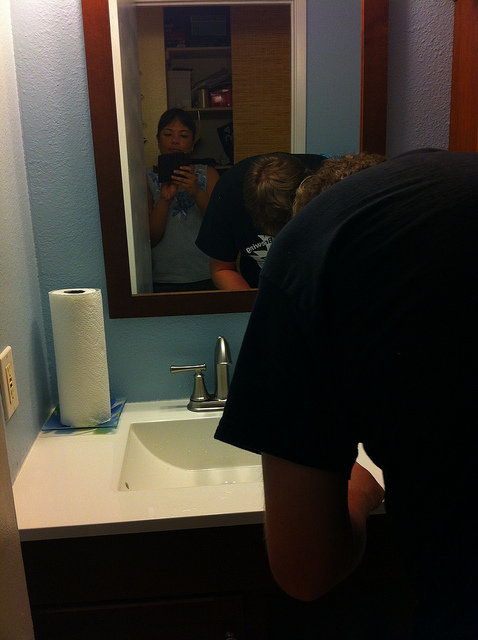<image>What time of year might it be? It is ambiguous what time of year it might be. The options seem to be summer, spring, or winter. What time of year might it be? It is ambiguous what time of year it might be. It could be summer, spring, or winter. 